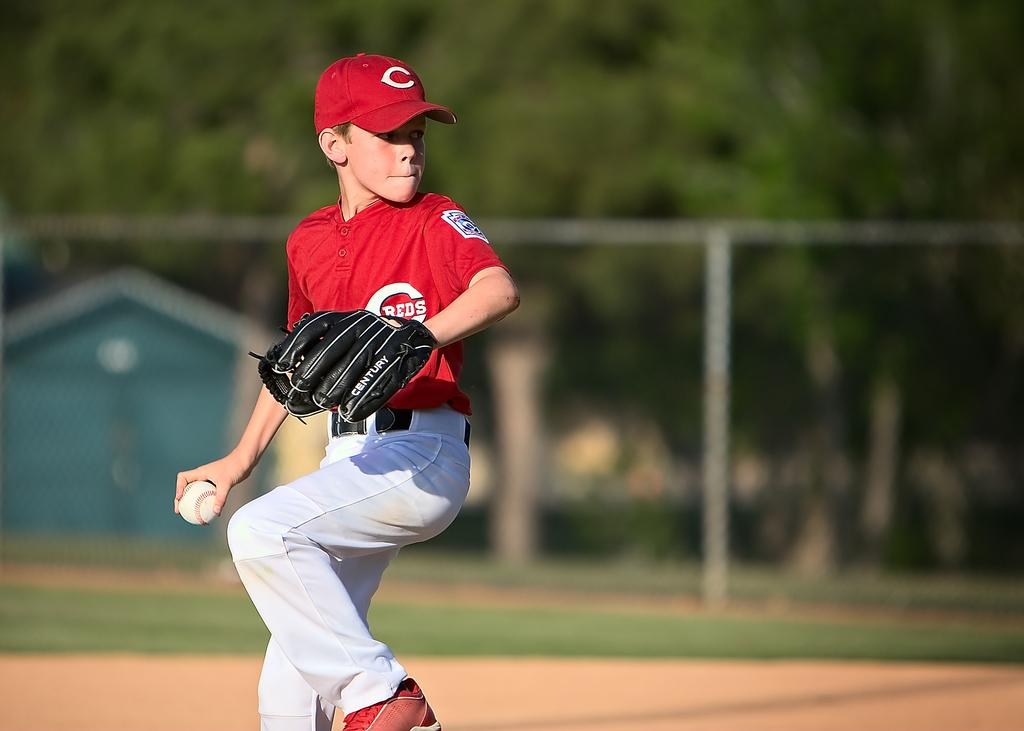Who is the main subject in the image? There is a boy in the image. What is the boy holding in the image? The boy is holding a ball. What type of environment is visible in the background of the image? There is grass and trees visible in the background of the image. How is the background of the image depicted? The background of the image is blurred. What type of soap is the boy using to draw a line in the image? There is no soap or line present in the image; the boy is holding a ball. 